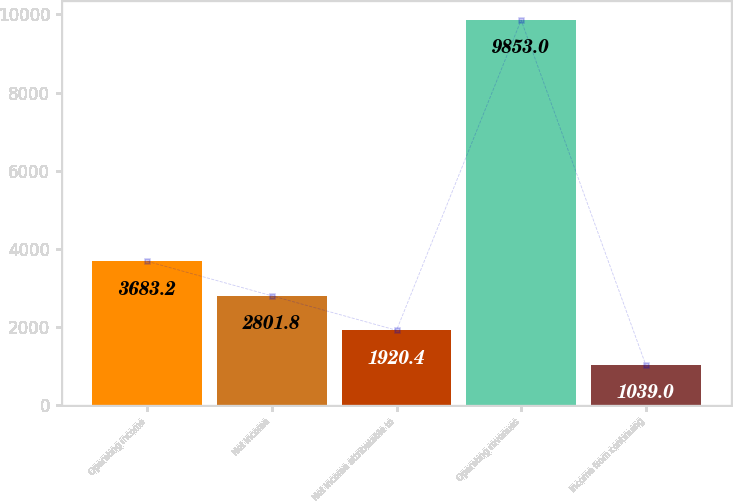Convert chart to OTSL. <chart><loc_0><loc_0><loc_500><loc_500><bar_chart><fcel>Operating income<fcel>Net income<fcel>Net income attributable to<fcel>Operating revenues<fcel>Income from continuing<nl><fcel>3683.2<fcel>2801.8<fcel>1920.4<fcel>9853<fcel>1039<nl></chart> 